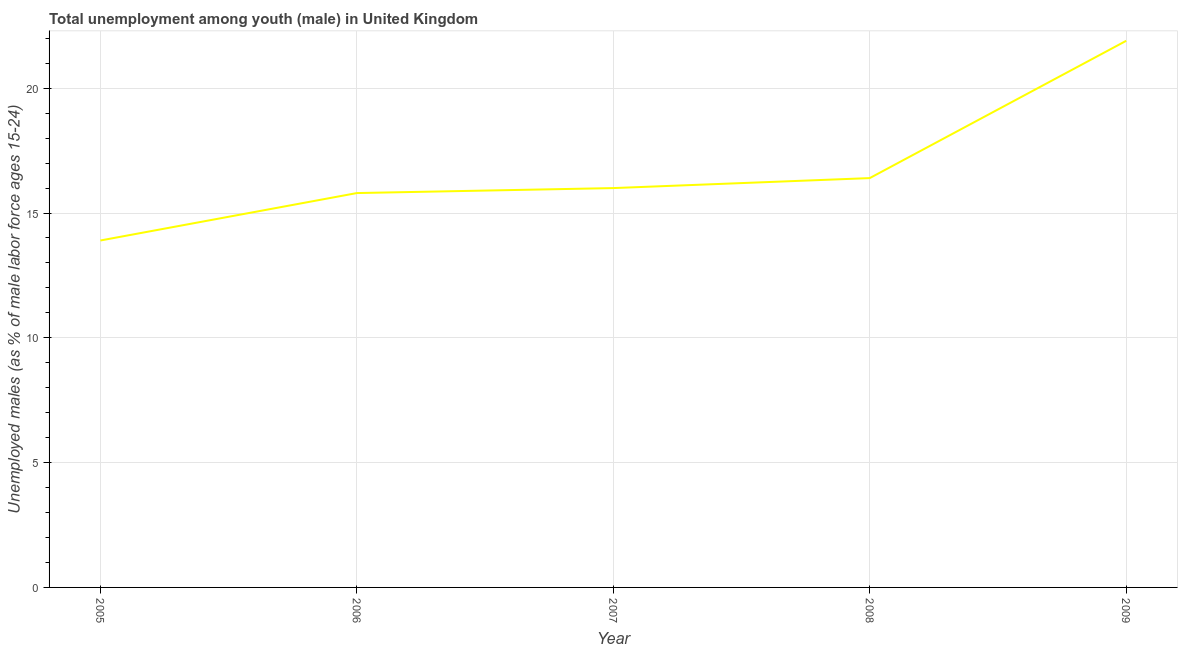Across all years, what is the maximum unemployed male youth population?
Offer a terse response. 21.9. Across all years, what is the minimum unemployed male youth population?
Give a very brief answer. 13.9. What is the sum of the unemployed male youth population?
Give a very brief answer. 84. What is the difference between the unemployed male youth population in 2005 and 2007?
Make the answer very short. -2.1. What is the average unemployed male youth population per year?
Provide a short and direct response. 16.8. What is the ratio of the unemployed male youth population in 2008 to that in 2009?
Your response must be concise. 0.75. Is the unemployed male youth population in 2005 less than that in 2006?
Give a very brief answer. Yes. Is the difference between the unemployed male youth population in 2006 and 2007 greater than the difference between any two years?
Give a very brief answer. No. What is the difference between the highest and the second highest unemployed male youth population?
Your response must be concise. 5.5. What is the difference between the highest and the lowest unemployed male youth population?
Ensure brevity in your answer.  8. In how many years, is the unemployed male youth population greater than the average unemployed male youth population taken over all years?
Offer a terse response. 1. Does the unemployed male youth population monotonically increase over the years?
Ensure brevity in your answer.  Yes. How many years are there in the graph?
Keep it short and to the point. 5. Are the values on the major ticks of Y-axis written in scientific E-notation?
Your answer should be very brief. No. Does the graph contain any zero values?
Your response must be concise. No. What is the title of the graph?
Give a very brief answer. Total unemployment among youth (male) in United Kingdom. What is the label or title of the Y-axis?
Provide a short and direct response. Unemployed males (as % of male labor force ages 15-24). What is the Unemployed males (as % of male labor force ages 15-24) in 2005?
Your answer should be very brief. 13.9. What is the Unemployed males (as % of male labor force ages 15-24) in 2006?
Offer a very short reply. 15.8. What is the Unemployed males (as % of male labor force ages 15-24) of 2007?
Provide a succinct answer. 16. What is the Unemployed males (as % of male labor force ages 15-24) in 2008?
Provide a short and direct response. 16.4. What is the Unemployed males (as % of male labor force ages 15-24) in 2009?
Keep it short and to the point. 21.9. What is the difference between the Unemployed males (as % of male labor force ages 15-24) in 2005 and 2009?
Keep it short and to the point. -8. What is the difference between the Unemployed males (as % of male labor force ages 15-24) in 2006 and 2008?
Ensure brevity in your answer.  -0.6. What is the difference between the Unemployed males (as % of male labor force ages 15-24) in 2007 and 2009?
Make the answer very short. -5.9. What is the ratio of the Unemployed males (as % of male labor force ages 15-24) in 2005 to that in 2006?
Your response must be concise. 0.88. What is the ratio of the Unemployed males (as % of male labor force ages 15-24) in 2005 to that in 2007?
Your answer should be very brief. 0.87. What is the ratio of the Unemployed males (as % of male labor force ages 15-24) in 2005 to that in 2008?
Give a very brief answer. 0.85. What is the ratio of the Unemployed males (as % of male labor force ages 15-24) in 2005 to that in 2009?
Provide a short and direct response. 0.64. What is the ratio of the Unemployed males (as % of male labor force ages 15-24) in 2006 to that in 2008?
Ensure brevity in your answer.  0.96. What is the ratio of the Unemployed males (as % of male labor force ages 15-24) in 2006 to that in 2009?
Offer a very short reply. 0.72. What is the ratio of the Unemployed males (as % of male labor force ages 15-24) in 2007 to that in 2008?
Your response must be concise. 0.98. What is the ratio of the Unemployed males (as % of male labor force ages 15-24) in 2007 to that in 2009?
Keep it short and to the point. 0.73. What is the ratio of the Unemployed males (as % of male labor force ages 15-24) in 2008 to that in 2009?
Provide a succinct answer. 0.75. 